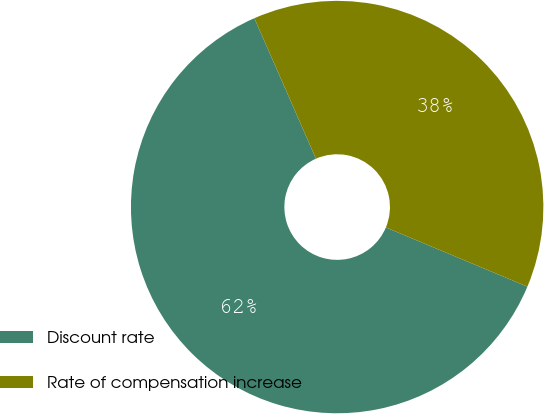Convert chart to OTSL. <chart><loc_0><loc_0><loc_500><loc_500><pie_chart><fcel>Discount rate<fcel>Rate of compensation increase<nl><fcel>62.12%<fcel>37.88%<nl></chart> 